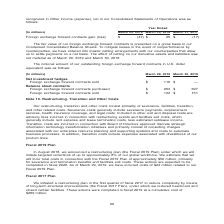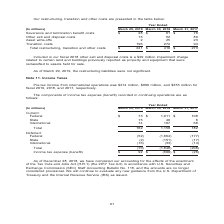According to Nortonlifelock's financial document, What does the table represent? Our restructuring, transition and other costs. The document states: "Our restructuring, transition and other costs consist primarily of severance, facilities, transition, and other related costs. Severance costs ge..." Also, What is the Severance and termination benefit costs for Year ended March 29,2019? According to the financial document, $28 (in millions). The relevant text states: "e completed in fiscal 2019 at a cumulative cost of $289 million...." Also, What is the Total restructuring, transition and other costs for Year ended March 29,2019? According to the financial document, $241 (in millions). The relevant text states: "Total restructuring, transition and other costs $ 241 $ 410 $ 273..." Also, can you calculate: What is the Total restructuring, transition and other costs for the fiscal years 2019, 2018, 2017? Based on the calculation: 241+410+273, the result is 924 (in millions). This is based on the information: "cturing, transition and other costs $ 241 $ 410 $ 273 Total restructuring, transition and other costs $ 241 $ 410 $ 273 restructuring, transition and other costs $ 241 $ 410 $ 273..." The key data points involved are: 241, 273, 410. Also, can you calculate: What is the average Total restructuring, transition and other costs for the fiscal years 2019, 2018, 2017? To answer this question, I need to perform calculations using the financial data. The calculation is: (241+410+273)/3, which equals 308 (in millions). This is based on the information: "cturing, transition and other costs $ 241 $ 410 $ 273 Total restructuring, transition and other costs $ 241 $ 410 $ 273 restructuring, transition and other costs $ 241 $ 410 $ 273..." The key data points involved are: 241, 273, 410. Also, can you calculate: What is the change in Total restructuring, transition and other costs from fiscal 2018 to fiscal 2019? Based on the calculation: 241-410, the result is -169 (in millions). This is based on the information: "Total restructuring, transition and other costs $ 241 $ 410 $ 273 restructuring, transition and other costs $ 241 $ 410 $ 273..." The key data points involved are: 241, 410. 